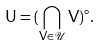<formula> <loc_0><loc_0><loc_500><loc_500>\mathsf U = ( \bigcap _ { \mathsf V \in \mathcal { U } } \mathsf V ) ^ { \circ } .</formula> 